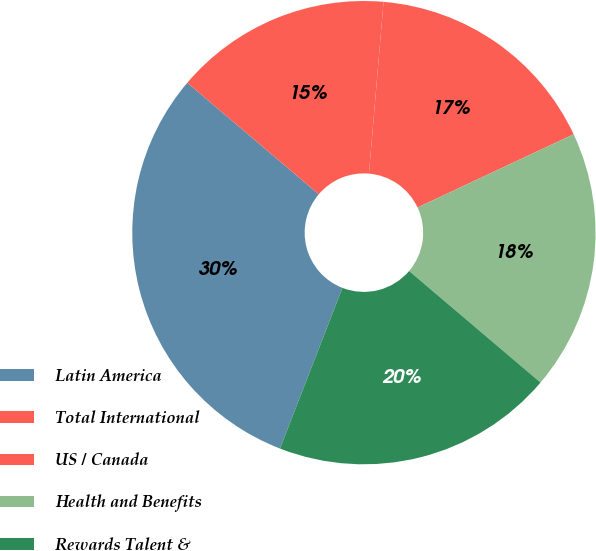Convert chart. <chart><loc_0><loc_0><loc_500><loc_500><pie_chart><fcel>Latin America<fcel>Total International<fcel>US / Canada<fcel>Health and Benefits<fcel>Rewards Talent &<nl><fcel>30.3%<fcel>15.15%<fcel>16.67%<fcel>18.18%<fcel>19.7%<nl></chart> 